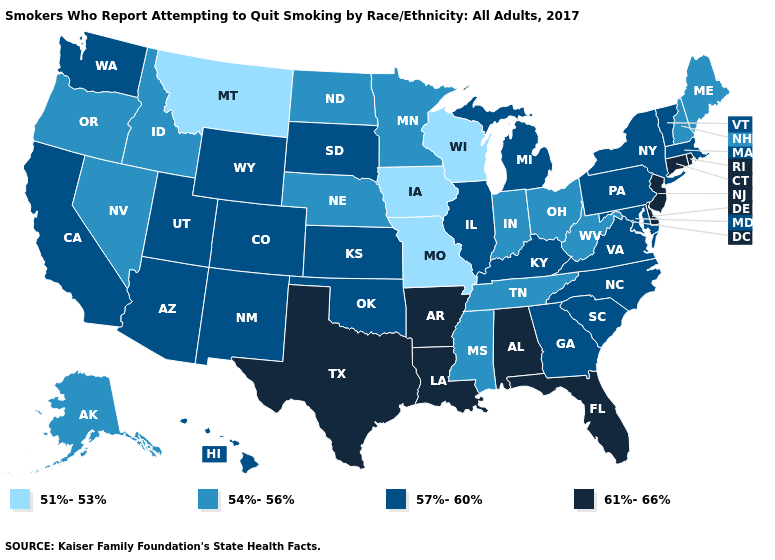What is the value of New Hampshire?
Be succinct. 54%-56%. Name the states that have a value in the range 61%-66%?
Keep it brief. Alabama, Arkansas, Connecticut, Delaware, Florida, Louisiana, New Jersey, Rhode Island, Texas. Does Wyoming have the lowest value in the West?
Concise answer only. No. Which states hav the highest value in the Northeast?
Short answer required. Connecticut, New Jersey, Rhode Island. Does Nevada have the highest value in the West?
Answer briefly. No. Which states hav the highest value in the MidWest?
Quick response, please. Illinois, Kansas, Michigan, South Dakota. Does Arkansas have the lowest value in the South?
Quick response, please. No. Does Nebraska have the same value as West Virginia?
Quick response, please. Yes. Which states hav the highest value in the MidWest?
Keep it brief. Illinois, Kansas, Michigan, South Dakota. Name the states that have a value in the range 61%-66%?
Give a very brief answer. Alabama, Arkansas, Connecticut, Delaware, Florida, Louisiana, New Jersey, Rhode Island, Texas. Does Hawaii have a higher value than Georgia?
Keep it brief. No. What is the value of Ohio?
Keep it brief. 54%-56%. Among the states that border New Mexico , does Utah have the lowest value?
Write a very short answer. Yes. What is the value of Oregon?
Give a very brief answer. 54%-56%. What is the value of Arizona?
Concise answer only. 57%-60%. 